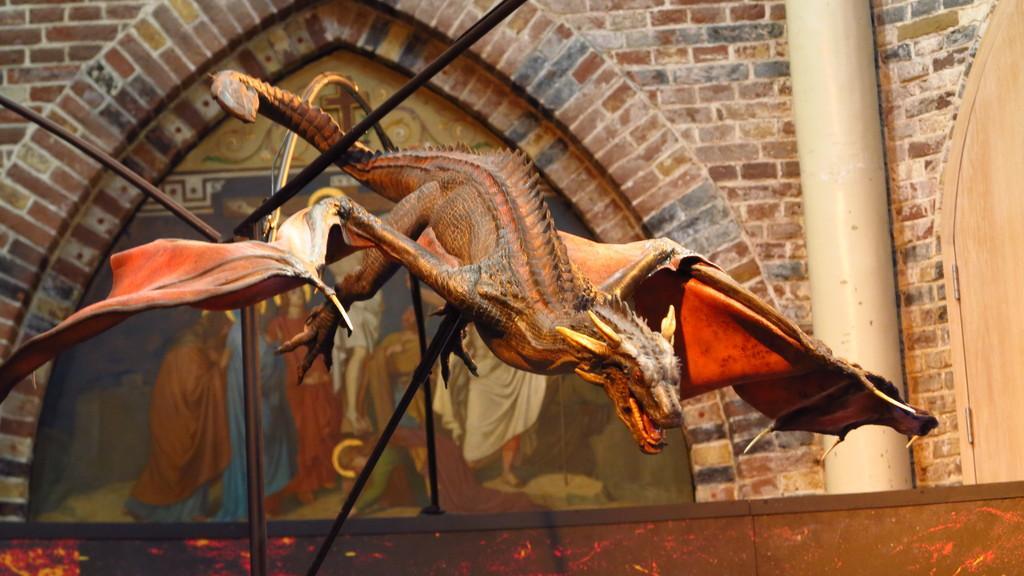In one or two sentences, can you explain what this image depicts? It is a thing which is in the shape of a dinosaur and on this wall there is a photo and this is a brick wall in the right side of an image. 